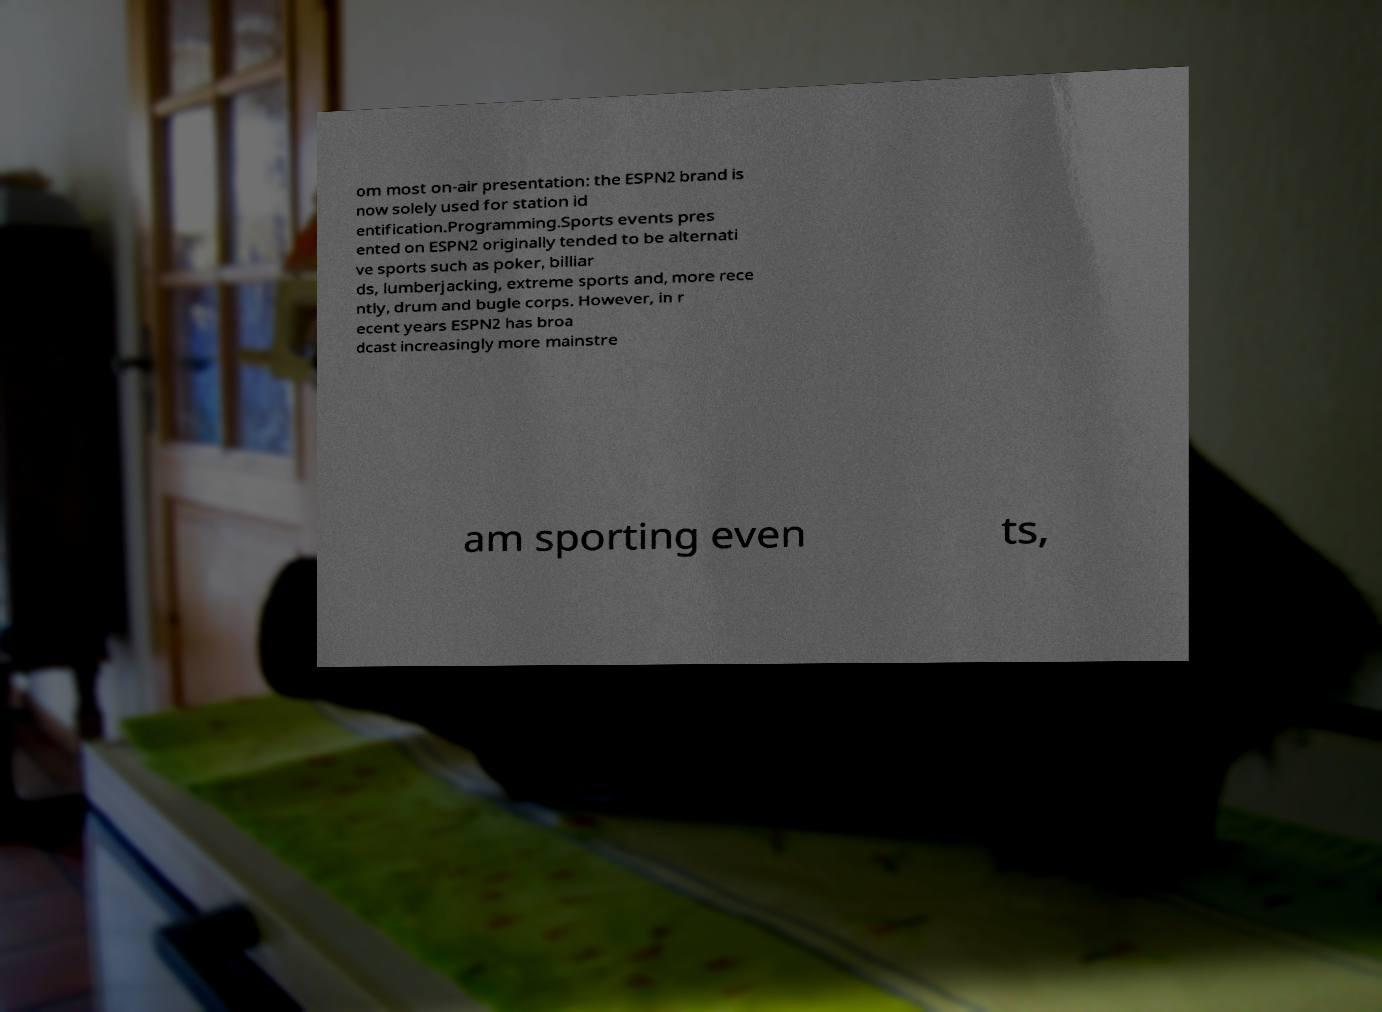What messages or text are displayed in this image? I need them in a readable, typed format. om most on-air presentation: the ESPN2 brand is now solely used for station id entification.Programming.Sports events pres ented on ESPN2 originally tended to be alternati ve sports such as poker, billiar ds, lumberjacking, extreme sports and, more rece ntly, drum and bugle corps. However, in r ecent years ESPN2 has broa dcast increasingly more mainstre am sporting even ts, 